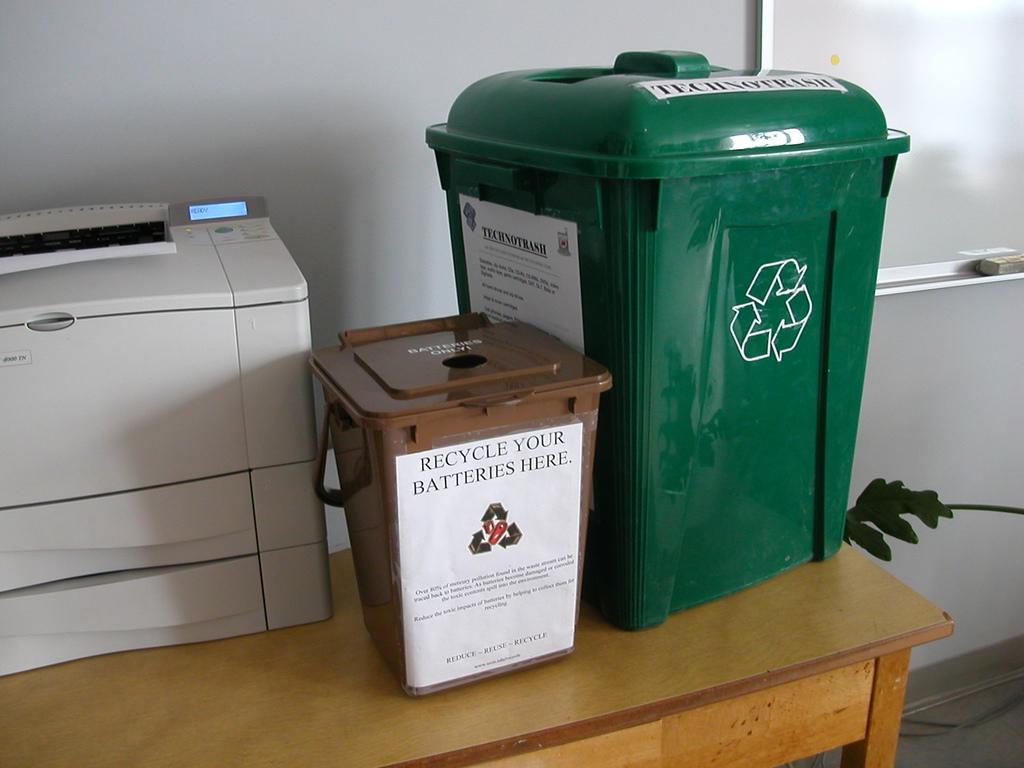How many bins are there?
Make the answer very short. 2. This is machine and tools box?
Offer a very short reply. No. 